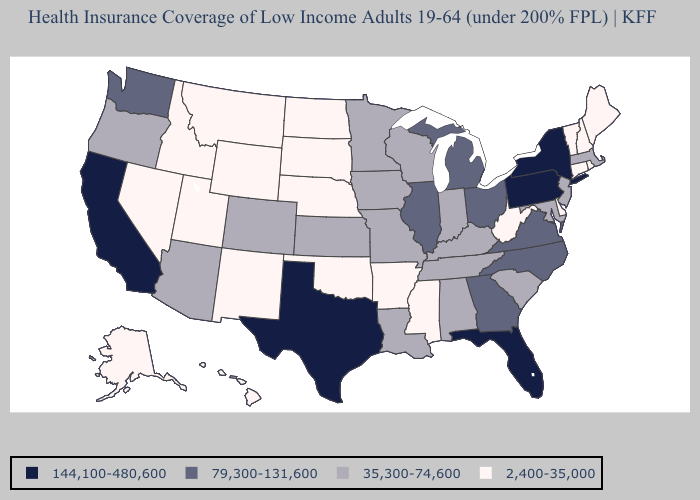What is the lowest value in the South?
Concise answer only. 2,400-35,000. Does Florida have the highest value in the South?
Quick response, please. Yes. Is the legend a continuous bar?
Concise answer only. No. Does Arkansas have a lower value than Maine?
Concise answer only. No. Name the states that have a value in the range 35,300-74,600?
Concise answer only. Alabama, Arizona, Colorado, Indiana, Iowa, Kansas, Kentucky, Louisiana, Maryland, Massachusetts, Minnesota, Missouri, New Jersey, Oregon, South Carolina, Tennessee, Wisconsin. What is the value of Michigan?
Write a very short answer. 79,300-131,600. What is the value of New Mexico?
Answer briefly. 2,400-35,000. What is the lowest value in the USA?
Write a very short answer. 2,400-35,000. What is the value of Montana?
Quick response, please. 2,400-35,000. Does Texas have the highest value in the USA?
Short answer required. Yes. Does Colorado have a higher value than Virginia?
Keep it brief. No. Name the states that have a value in the range 79,300-131,600?
Give a very brief answer. Georgia, Illinois, Michigan, North Carolina, Ohio, Virginia, Washington. What is the value of Kentucky?
Quick response, please. 35,300-74,600. Name the states that have a value in the range 2,400-35,000?
Short answer required. Alaska, Arkansas, Connecticut, Delaware, Hawaii, Idaho, Maine, Mississippi, Montana, Nebraska, Nevada, New Hampshire, New Mexico, North Dakota, Oklahoma, Rhode Island, South Dakota, Utah, Vermont, West Virginia, Wyoming. Does the map have missing data?
Quick response, please. No. 